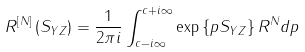Convert formula to latex. <formula><loc_0><loc_0><loc_500><loc_500>R ^ { \left [ N \right ] } \left ( S _ { Y Z } \right ) = \frac { 1 } { 2 \pi i } \int _ { c - i \infty } ^ { c + i \infty } \exp \left \{ p S _ { Y Z } \right \} R ^ { N } d p</formula> 